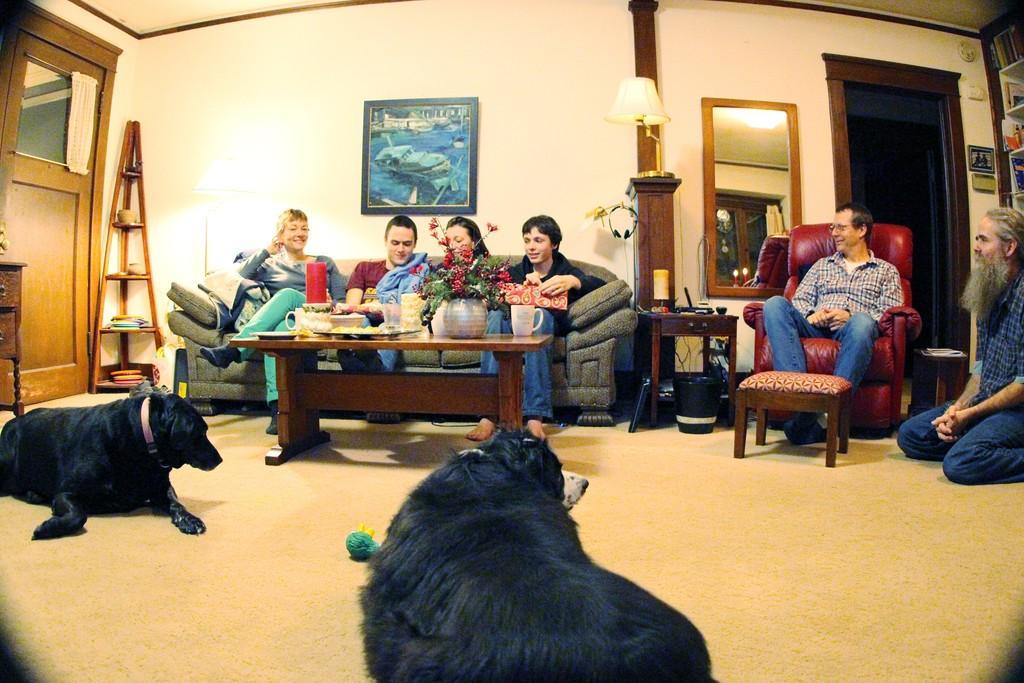How would you summarize this image in a sentence or two? In this picture we can see two dogs and couple of people, few persons are seated on the sofa and one person is seated on the floor, in the background we can see a light and a wall painting. 